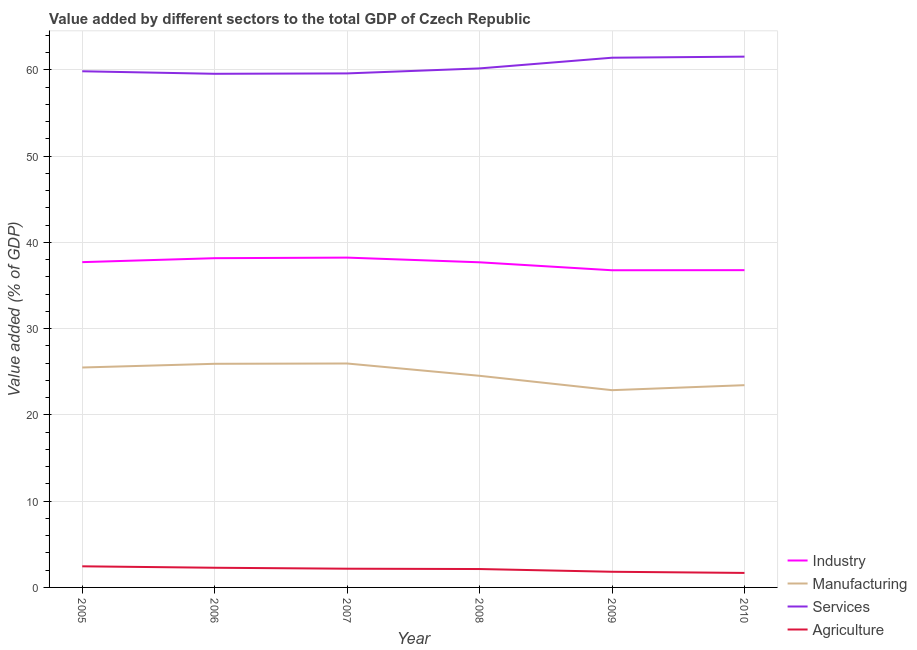How many different coloured lines are there?
Your answer should be very brief. 4. What is the value added by agricultural sector in 2010?
Offer a terse response. 1.68. Across all years, what is the maximum value added by industrial sector?
Your answer should be very brief. 38.24. Across all years, what is the minimum value added by industrial sector?
Your answer should be very brief. 36.77. What is the total value added by services sector in the graph?
Offer a terse response. 362.1. What is the difference between the value added by manufacturing sector in 2009 and that in 2010?
Provide a short and direct response. -0.58. What is the difference between the value added by industrial sector in 2009 and the value added by manufacturing sector in 2010?
Offer a very short reply. 13.32. What is the average value added by services sector per year?
Your answer should be compact. 60.35. In the year 2005, what is the difference between the value added by industrial sector and value added by services sector?
Keep it short and to the point. -22.13. In how many years, is the value added by manufacturing sector greater than 14 %?
Make the answer very short. 6. What is the ratio of the value added by services sector in 2007 to that in 2009?
Offer a terse response. 0.97. Is the value added by manufacturing sector in 2005 less than that in 2008?
Offer a terse response. No. What is the difference between the highest and the second highest value added by industrial sector?
Your answer should be compact. 0.07. What is the difference between the highest and the lowest value added by industrial sector?
Your answer should be very brief. 1.47. Is it the case that in every year, the sum of the value added by industrial sector and value added by manufacturing sector is greater than the value added by services sector?
Your answer should be very brief. No. Is the value added by industrial sector strictly greater than the value added by agricultural sector over the years?
Offer a very short reply. Yes. How many lines are there?
Keep it short and to the point. 4. Are the values on the major ticks of Y-axis written in scientific E-notation?
Keep it short and to the point. No. Does the graph contain any zero values?
Your answer should be compact. No. Where does the legend appear in the graph?
Your answer should be compact. Bottom right. How many legend labels are there?
Provide a succinct answer. 4. What is the title of the graph?
Give a very brief answer. Value added by different sectors to the total GDP of Czech Republic. Does "Payroll services" appear as one of the legend labels in the graph?
Provide a short and direct response. No. What is the label or title of the X-axis?
Give a very brief answer. Year. What is the label or title of the Y-axis?
Offer a very short reply. Value added (% of GDP). What is the Value added (% of GDP) in Industry in 2005?
Your answer should be very brief. 37.71. What is the Value added (% of GDP) of Manufacturing in 2005?
Ensure brevity in your answer.  25.5. What is the Value added (% of GDP) in Services in 2005?
Your answer should be very brief. 59.84. What is the Value added (% of GDP) of Agriculture in 2005?
Ensure brevity in your answer.  2.45. What is the Value added (% of GDP) of Industry in 2006?
Ensure brevity in your answer.  38.17. What is the Value added (% of GDP) in Manufacturing in 2006?
Provide a short and direct response. 25.93. What is the Value added (% of GDP) of Services in 2006?
Offer a terse response. 59.55. What is the Value added (% of GDP) of Agriculture in 2006?
Provide a succinct answer. 2.28. What is the Value added (% of GDP) of Industry in 2007?
Keep it short and to the point. 38.24. What is the Value added (% of GDP) of Manufacturing in 2007?
Ensure brevity in your answer.  25.96. What is the Value added (% of GDP) of Services in 2007?
Your answer should be very brief. 59.59. What is the Value added (% of GDP) in Agriculture in 2007?
Your answer should be very brief. 2.17. What is the Value added (% of GDP) in Industry in 2008?
Your answer should be very brief. 37.69. What is the Value added (% of GDP) of Manufacturing in 2008?
Ensure brevity in your answer.  24.53. What is the Value added (% of GDP) in Services in 2008?
Provide a succinct answer. 60.17. What is the Value added (% of GDP) in Agriculture in 2008?
Your answer should be compact. 2.13. What is the Value added (% of GDP) in Industry in 2009?
Offer a very short reply. 36.77. What is the Value added (% of GDP) in Manufacturing in 2009?
Your answer should be compact. 22.87. What is the Value added (% of GDP) of Services in 2009?
Provide a short and direct response. 61.41. What is the Value added (% of GDP) in Agriculture in 2009?
Offer a terse response. 1.82. What is the Value added (% of GDP) in Industry in 2010?
Ensure brevity in your answer.  36.78. What is the Value added (% of GDP) of Manufacturing in 2010?
Keep it short and to the point. 23.45. What is the Value added (% of GDP) of Services in 2010?
Provide a succinct answer. 61.54. What is the Value added (% of GDP) in Agriculture in 2010?
Your answer should be very brief. 1.68. Across all years, what is the maximum Value added (% of GDP) of Industry?
Provide a succinct answer. 38.24. Across all years, what is the maximum Value added (% of GDP) of Manufacturing?
Your answer should be very brief. 25.96. Across all years, what is the maximum Value added (% of GDP) of Services?
Your response must be concise. 61.54. Across all years, what is the maximum Value added (% of GDP) in Agriculture?
Provide a succinct answer. 2.45. Across all years, what is the minimum Value added (% of GDP) in Industry?
Offer a terse response. 36.77. Across all years, what is the minimum Value added (% of GDP) of Manufacturing?
Ensure brevity in your answer.  22.87. Across all years, what is the minimum Value added (% of GDP) of Services?
Your response must be concise. 59.55. Across all years, what is the minimum Value added (% of GDP) in Agriculture?
Give a very brief answer. 1.68. What is the total Value added (% of GDP) in Industry in the graph?
Provide a short and direct response. 225.37. What is the total Value added (% of GDP) of Manufacturing in the graph?
Ensure brevity in your answer.  148.24. What is the total Value added (% of GDP) in Services in the graph?
Your response must be concise. 362.1. What is the total Value added (% of GDP) of Agriculture in the graph?
Your response must be concise. 12.53. What is the difference between the Value added (% of GDP) of Industry in 2005 and that in 2006?
Provide a succinct answer. -0.46. What is the difference between the Value added (% of GDP) in Manufacturing in 2005 and that in 2006?
Offer a terse response. -0.43. What is the difference between the Value added (% of GDP) of Services in 2005 and that in 2006?
Provide a short and direct response. 0.29. What is the difference between the Value added (% of GDP) of Agriculture in 2005 and that in 2006?
Keep it short and to the point. 0.17. What is the difference between the Value added (% of GDP) of Industry in 2005 and that in 2007?
Give a very brief answer. -0.53. What is the difference between the Value added (% of GDP) of Manufacturing in 2005 and that in 2007?
Give a very brief answer. -0.46. What is the difference between the Value added (% of GDP) in Services in 2005 and that in 2007?
Your answer should be compact. 0.25. What is the difference between the Value added (% of GDP) in Agriculture in 2005 and that in 2007?
Give a very brief answer. 0.28. What is the difference between the Value added (% of GDP) in Industry in 2005 and that in 2008?
Keep it short and to the point. 0.02. What is the difference between the Value added (% of GDP) in Manufacturing in 2005 and that in 2008?
Offer a terse response. 0.96. What is the difference between the Value added (% of GDP) of Services in 2005 and that in 2008?
Your answer should be very brief. -0.33. What is the difference between the Value added (% of GDP) in Agriculture in 2005 and that in 2008?
Your answer should be compact. 0.31. What is the difference between the Value added (% of GDP) of Industry in 2005 and that in 2009?
Provide a succinct answer. 0.94. What is the difference between the Value added (% of GDP) of Manufacturing in 2005 and that in 2009?
Ensure brevity in your answer.  2.63. What is the difference between the Value added (% of GDP) of Services in 2005 and that in 2009?
Make the answer very short. -1.57. What is the difference between the Value added (% of GDP) of Agriculture in 2005 and that in 2009?
Offer a terse response. 0.63. What is the difference between the Value added (% of GDP) in Industry in 2005 and that in 2010?
Provide a succinct answer. 0.93. What is the difference between the Value added (% of GDP) of Manufacturing in 2005 and that in 2010?
Your response must be concise. 2.05. What is the difference between the Value added (% of GDP) in Services in 2005 and that in 2010?
Your answer should be very brief. -1.7. What is the difference between the Value added (% of GDP) in Agriculture in 2005 and that in 2010?
Provide a short and direct response. 0.77. What is the difference between the Value added (% of GDP) of Industry in 2006 and that in 2007?
Your answer should be very brief. -0.07. What is the difference between the Value added (% of GDP) of Manufacturing in 2006 and that in 2007?
Offer a terse response. -0.04. What is the difference between the Value added (% of GDP) in Services in 2006 and that in 2007?
Your answer should be very brief. -0.05. What is the difference between the Value added (% of GDP) in Agriculture in 2006 and that in 2007?
Provide a short and direct response. 0.11. What is the difference between the Value added (% of GDP) of Industry in 2006 and that in 2008?
Offer a very short reply. 0.48. What is the difference between the Value added (% of GDP) of Manufacturing in 2006 and that in 2008?
Ensure brevity in your answer.  1.39. What is the difference between the Value added (% of GDP) of Services in 2006 and that in 2008?
Your answer should be very brief. -0.63. What is the difference between the Value added (% of GDP) of Agriculture in 2006 and that in 2008?
Keep it short and to the point. 0.15. What is the difference between the Value added (% of GDP) in Industry in 2006 and that in 2009?
Your answer should be very brief. 1.4. What is the difference between the Value added (% of GDP) of Manufacturing in 2006 and that in 2009?
Offer a terse response. 3.06. What is the difference between the Value added (% of GDP) in Services in 2006 and that in 2009?
Your answer should be compact. -1.87. What is the difference between the Value added (% of GDP) of Agriculture in 2006 and that in 2009?
Your response must be concise. 0.47. What is the difference between the Value added (% of GDP) in Industry in 2006 and that in 2010?
Provide a short and direct response. 1.39. What is the difference between the Value added (% of GDP) of Manufacturing in 2006 and that in 2010?
Ensure brevity in your answer.  2.48. What is the difference between the Value added (% of GDP) of Services in 2006 and that in 2010?
Give a very brief answer. -1.99. What is the difference between the Value added (% of GDP) in Agriculture in 2006 and that in 2010?
Give a very brief answer. 0.6. What is the difference between the Value added (% of GDP) of Industry in 2007 and that in 2008?
Your answer should be compact. 0.54. What is the difference between the Value added (% of GDP) in Manufacturing in 2007 and that in 2008?
Your response must be concise. 1.43. What is the difference between the Value added (% of GDP) in Services in 2007 and that in 2008?
Give a very brief answer. -0.58. What is the difference between the Value added (% of GDP) in Agriculture in 2007 and that in 2008?
Keep it short and to the point. 0.04. What is the difference between the Value added (% of GDP) in Industry in 2007 and that in 2009?
Your response must be concise. 1.47. What is the difference between the Value added (% of GDP) in Manufacturing in 2007 and that in 2009?
Your response must be concise. 3.09. What is the difference between the Value added (% of GDP) in Services in 2007 and that in 2009?
Your answer should be compact. -1.82. What is the difference between the Value added (% of GDP) in Agriculture in 2007 and that in 2009?
Your answer should be compact. 0.35. What is the difference between the Value added (% of GDP) of Industry in 2007 and that in 2010?
Provide a short and direct response. 1.45. What is the difference between the Value added (% of GDP) of Manufacturing in 2007 and that in 2010?
Your answer should be compact. 2.51. What is the difference between the Value added (% of GDP) of Services in 2007 and that in 2010?
Your answer should be very brief. -1.94. What is the difference between the Value added (% of GDP) in Agriculture in 2007 and that in 2010?
Keep it short and to the point. 0.49. What is the difference between the Value added (% of GDP) of Industry in 2008 and that in 2009?
Your answer should be very brief. 0.92. What is the difference between the Value added (% of GDP) in Manufacturing in 2008 and that in 2009?
Make the answer very short. 1.67. What is the difference between the Value added (% of GDP) in Services in 2008 and that in 2009?
Offer a terse response. -1.24. What is the difference between the Value added (% of GDP) of Agriculture in 2008 and that in 2009?
Offer a very short reply. 0.32. What is the difference between the Value added (% of GDP) of Industry in 2008 and that in 2010?
Provide a short and direct response. 0.91. What is the difference between the Value added (% of GDP) in Manufacturing in 2008 and that in 2010?
Offer a terse response. 1.09. What is the difference between the Value added (% of GDP) in Services in 2008 and that in 2010?
Your answer should be very brief. -1.36. What is the difference between the Value added (% of GDP) of Agriculture in 2008 and that in 2010?
Your answer should be compact. 0.45. What is the difference between the Value added (% of GDP) in Industry in 2009 and that in 2010?
Your answer should be very brief. -0.01. What is the difference between the Value added (% of GDP) of Manufacturing in 2009 and that in 2010?
Ensure brevity in your answer.  -0.58. What is the difference between the Value added (% of GDP) in Services in 2009 and that in 2010?
Your answer should be compact. -0.12. What is the difference between the Value added (% of GDP) in Agriculture in 2009 and that in 2010?
Provide a succinct answer. 0.14. What is the difference between the Value added (% of GDP) of Industry in 2005 and the Value added (% of GDP) of Manufacturing in 2006?
Provide a short and direct response. 11.79. What is the difference between the Value added (% of GDP) in Industry in 2005 and the Value added (% of GDP) in Services in 2006?
Provide a succinct answer. -21.84. What is the difference between the Value added (% of GDP) in Industry in 2005 and the Value added (% of GDP) in Agriculture in 2006?
Your answer should be compact. 35.43. What is the difference between the Value added (% of GDP) in Manufacturing in 2005 and the Value added (% of GDP) in Services in 2006?
Provide a short and direct response. -34.05. What is the difference between the Value added (% of GDP) in Manufacturing in 2005 and the Value added (% of GDP) in Agriculture in 2006?
Keep it short and to the point. 23.21. What is the difference between the Value added (% of GDP) of Services in 2005 and the Value added (% of GDP) of Agriculture in 2006?
Provide a succinct answer. 57.56. What is the difference between the Value added (% of GDP) of Industry in 2005 and the Value added (% of GDP) of Manufacturing in 2007?
Provide a short and direct response. 11.75. What is the difference between the Value added (% of GDP) in Industry in 2005 and the Value added (% of GDP) in Services in 2007?
Your answer should be very brief. -21.88. What is the difference between the Value added (% of GDP) of Industry in 2005 and the Value added (% of GDP) of Agriculture in 2007?
Provide a succinct answer. 35.54. What is the difference between the Value added (% of GDP) of Manufacturing in 2005 and the Value added (% of GDP) of Services in 2007?
Ensure brevity in your answer.  -34.1. What is the difference between the Value added (% of GDP) in Manufacturing in 2005 and the Value added (% of GDP) in Agriculture in 2007?
Ensure brevity in your answer.  23.33. What is the difference between the Value added (% of GDP) of Services in 2005 and the Value added (% of GDP) of Agriculture in 2007?
Provide a succinct answer. 57.67. What is the difference between the Value added (% of GDP) in Industry in 2005 and the Value added (% of GDP) in Manufacturing in 2008?
Offer a terse response. 13.18. What is the difference between the Value added (% of GDP) of Industry in 2005 and the Value added (% of GDP) of Services in 2008?
Provide a succinct answer. -22.46. What is the difference between the Value added (% of GDP) in Industry in 2005 and the Value added (% of GDP) in Agriculture in 2008?
Your answer should be very brief. 35.58. What is the difference between the Value added (% of GDP) in Manufacturing in 2005 and the Value added (% of GDP) in Services in 2008?
Keep it short and to the point. -34.68. What is the difference between the Value added (% of GDP) in Manufacturing in 2005 and the Value added (% of GDP) in Agriculture in 2008?
Provide a succinct answer. 23.36. What is the difference between the Value added (% of GDP) of Services in 2005 and the Value added (% of GDP) of Agriculture in 2008?
Offer a terse response. 57.71. What is the difference between the Value added (% of GDP) in Industry in 2005 and the Value added (% of GDP) in Manufacturing in 2009?
Your answer should be compact. 14.84. What is the difference between the Value added (% of GDP) in Industry in 2005 and the Value added (% of GDP) in Services in 2009?
Ensure brevity in your answer.  -23.7. What is the difference between the Value added (% of GDP) in Industry in 2005 and the Value added (% of GDP) in Agriculture in 2009?
Your response must be concise. 35.9. What is the difference between the Value added (% of GDP) of Manufacturing in 2005 and the Value added (% of GDP) of Services in 2009?
Your response must be concise. -35.92. What is the difference between the Value added (% of GDP) in Manufacturing in 2005 and the Value added (% of GDP) in Agriculture in 2009?
Offer a very short reply. 23.68. What is the difference between the Value added (% of GDP) of Services in 2005 and the Value added (% of GDP) of Agriculture in 2009?
Make the answer very short. 58.03. What is the difference between the Value added (% of GDP) in Industry in 2005 and the Value added (% of GDP) in Manufacturing in 2010?
Offer a very short reply. 14.26. What is the difference between the Value added (% of GDP) in Industry in 2005 and the Value added (% of GDP) in Services in 2010?
Ensure brevity in your answer.  -23.83. What is the difference between the Value added (% of GDP) of Industry in 2005 and the Value added (% of GDP) of Agriculture in 2010?
Provide a short and direct response. 36.03. What is the difference between the Value added (% of GDP) of Manufacturing in 2005 and the Value added (% of GDP) of Services in 2010?
Make the answer very short. -36.04. What is the difference between the Value added (% of GDP) in Manufacturing in 2005 and the Value added (% of GDP) in Agriculture in 2010?
Your answer should be very brief. 23.82. What is the difference between the Value added (% of GDP) in Services in 2005 and the Value added (% of GDP) in Agriculture in 2010?
Make the answer very short. 58.16. What is the difference between the Value added (% of GDP) of Industry in 2006 and the Value added (% of GDP) of Manufacturing in 2007?
Your answer should be very brief. 12.21. What is the difference between the Value added (% of GDP) of Industry in 2006 and the Value added (% of GDP) of Services in 2007?
Provide a short and direct response. -21.42. What is the difference between the Value added (% of GDP) of Industry in 2006 and the Value added (% of GDP) of Agriculture in 2007?
Provide a short and direct response. 36. What is the difference between the Value added (% of GDP) in Manufacturing in 2006 and the Value added (% of GDP) in Services in 2007?
Keep it short and to the point. -33.67. What is the difference between the Value added (% of GDP) in Manufacturing in 2006 and the Value added (% of GDP) in Agriculture in 2007?
Make the answer very short. 23.76. What is the difference between the Value added (% of GDP) in Services in 2006 and the Value added (% of GDP) in Agriculture in 2007?
Your answer should be compact. 57.38. What is the difference between the Value added (% of GDP) of Industry in 2006 and the Value added (% of GDP) of Manufacturing in 2008?
Your response must be concise. 13.64. What is the difference between the Value added (% of GDP) of Industry in 2006 and the Value added (% of GDP) of Services in 2008?
Give a very brief answer. -22. What is the difference between the Value added (% of GDP) in Industry in 2006 and the Value added (% of GDP) in Agriculture in 2008?
Your answer should be compact. 36.04. What is the difference between the Value added (% of GDP) of Manufacturing in 2006 and the Value added (% of GDP) of Services in 2008?
Offer a terse response. -34.25. What is the difference between the Value added (% of GDP) of Manufacturing in 2006 and the Value added (% of GDP) of Agriculture in 2008?
Provide a short and direct response. 23.79. What is the difference between the Value added (% of GDP) in Services in 2006 and the Value added (% of GDP) in Agriculture in 2008?
Your answer should be very brief. 57.41. What is the difference between the Value added (% of GDP) of Industry in 2006 and the Value added (% of GDP) of Manufacturing in 2009?
Your response must be concise. 15.3. What is the difference between the Value added (% of GDP) of Industry in 2006 and the Value added (% of GDP) of Services in 2009?
Ensure brevity in your answer.  -23.24. What is the difference between the Value added (% of GDP) of Industry in 2006 and the Value added (% of GDP) of Agriculture in 2009?
Give a very brief answer. 36.36. What is the difference between the Value added (% of GDP) in Manufacturing in 2006 and the Value added (% of GDP) in Services in 2009?
Your response must be concise. -35.49. What is the difference between the Value added (% of GDP) of Manufacturing in 2006 and the Value added (% of GDP) of Agriculture in 2009?
Your answer should be compact. 24.11. What is the difference between the Value added (% of GDP) in Services in 2006 and the Value added (% of GDP) in Agriculture in 2009?
Your answer should be compact. 57.73. What is the difference between the Value added (% of GDP) of Industry in 2006 and the Value added (% of GDP) of Manufacturing in 2010?
Provide a succinct answer. 14.72. What is the difference between the Value added (% of GDP) of Industry in 2006 and the Value added (% of GDP) of Services in 2010?
Your response must be concise. -23.37. What is the difference between the Value added (% of GDP) of Industry in 2006 and the Value added (% of GDP) of Agriculture in 2010?
Offer a terse response. 36.49. What is the difference between the Value added (% of GDP) of Manufacturing in 2006 and the Value added (% of GDP) of Services in 2010?
Your answer should be very brief. -35.61. What is the difference between the Value added (% of GDP) of Manufacturing in 2006 and the Value added (% of GDP) of Agriculture in 2010?
Your answer should be very brief. 24.25. What is the difference between the Value added (% of GDP) of Services in 2006 and the Value added (% of GDP) of Agriculture in 2010?
Your answer should be very brief. 57.87. What is the difference between the Value added (% of GDP) in Industry in 2007 and the Value added (% of GDP) in Manufacturing in 2008?
Make the answer very short. 13.7. What is the difference between the Value added (% of GDP) in Industry in 2007 and the Value added (% of GDP) in Services in 2008?
Ensure brevity in your answer.  -21.94. What is the difference between the Value added (% of GDP) of Industry in 2007 and the Value added (% of GDP) of Agriculture in 2008?
Your answer should be compact. 36.1. What is the difference between the Value added (% of GDP) in Manufacturing in 2007 and the Value added (% of GDP) in Services in 2008?
Your answer should be very brief. -34.21. What is the difference between the Value added (% of GDP) in Manufacturing in 2007 and the Value added (% of GDP) in Agriculture in 2008?
Offer a very short reply. 23.83. What is the difference between the Value added (% of GDP) of Services in 2007 and the Value added (% of GDP) of Agriculture in 2008?
Keep it short and to the point. 57.46. What is the difference between the Value added (% of GDP) of Industry in 2007 and the Value added (% of GDP) of Manufacturing in 2009?
Your answer should be very brief. 15.37. What is the difference between the Value added (% of GDP) in Industry in 2007 and the Value added (% of GDP) in Services in 2009?
Give a very brief answer. -23.18. What is the difference between the Value added (% of GDP) of Industry in 2007 and the Value added (% of GDP) of Agriculture in 2009?
Offer a terse response. 36.42. What is the difference between the Value added (% of GDP) of Manufacturing in 2007 and the Value added (% of GDP) of Services in 2009?
Ensure brevity in your answer.  -35.45. What is the difference between the Value added (% of GDP) in Manufacturing in 2007 and the Value added (% of GDP) in Agriculture in 2009?
Offer a very short reply. 24.15. What is the difference between the Value added (% of GDP) in Services in 2007 and the Value added (% of GDP) in Agriculture in 2009?
Your answer should be very brief. 57.78. What is the difference between the Value added (% of GDP) of Industry in 2007 and the Value added (% of GDP) of Manufacturing in 2010?
Offer a very short reply. 14.79. What is the difference between the Value added (% of GDP) of Industry in 2007 and the Value added (% of GDP) of Services in 2010?
Provide a short and direct response. -23.3. What is the difference between the Value added (% of GDP) in Industry in 2007 and the Value added (% of GDP) in Agriculture in 2010?
Keep it short and to the point. 36.56. What is the difference between the Value added (% of GDP) of Manufacturing in 2007 and the Value added (% of GDP) of Services in 2010?
Your answer should be compact. -35.58. What is the difference between the Value added (% of GDP) of Manufacturing in 2007 and the Value added (% of GDP) of Agriculture in 2010?
Make the answer very short. 24.28. What is the difference between the Value added (% of GDP) in Services in 2007 and the Value added (% of GDP) in Agriculture in 2010?
Ensure brevity in your answer.  57.91. What is the difference between the Value added (% of GDP) of Industry in 2008 and the Value added (% of GDP) of Manufacturing in 2009?
Keep it short and to the point. 14.82. What is the difference between the Value added (% of GDP) of Industry in 2008 and the Value added (% of GDP) of Services in 2009?
Ensure brevity in your answer.  -23.72. What is the difference between the Value added (% of GDP) in Industry in 2008 and the Value added (% of GDP) in Agriculture in 2009?
Give a very brief answer. 35.88. What is the difference between the Value added (% of GDP) in Manufacturing in 2008 and the Value added (% of GDP) in Services in 2009?
Make the answer very short. -36.88. What is the difference between the Value added (% of GDP) of Manufacturing in 2008 and the Value added (% of GDP) of Agriculture in 2009?
Offer a very short reply. 22.72. What is the difference between the Value added (% of GDP) of Services in 2008 and the Value added (% of GDP) of Agriculture in 2009?
Provide a succinct answer. 58.36. What is the difference between the Value added (% of GDP) in Industry in 2008 and the Value added (% of GDP) in Manufacturing in 2010?
Offer a very short reply. 14.24. What is the difference between the Value added (% of GDP) of Industry in 2008 and the Value added (% of GDP) of Services in 2010?
Provide a succinct answer. -23.84. What is the difference between the Value added (% of GDP) of Industry in 2008 and the Value added (% of GDP) of Agriculture in 2010?
Keep it short and to the point. 36.01. What is the difference between the Value added (% of GDP) in Manufacturing in 2008 and the Value added (% of GDP) in Services in 2010?
Offer a very short reply. -37. What is the difference between the Value added (% of GDP) of Manufacturing in 2008 and the Value added (% of GDP) of Agriculture in 2010?
Your answer should be very brief. 22.85. What is the difference between the Value added (% of GDP) of Services in 2008 and the Value added (% of GDP) of Agriculture in 2010?
Keep it short and to the point. 58.49. What is the difference between the Value added (% of GDP) of Industry in 2009 and the Value added (% of GDP) of Manufacturing in 2010?
Your answer should be very brief. 13.32. What is the difference between the Value added (% of GDP) in Industry in 2009 and the Value added (% of GDP) in Services in 2010?
Ensure brevity in your answer.  -24.77. What is the difference between the Value added (% of GDP) in Industry in 2009 and the Value added (% of GDP) in Agriculture in 2010?
Provide a short and direct response. 35.09. What is the difference between the Value added (% of GDP) of Manufacturing in 2009 and the Value added (% of GDP) of Services in 2010?
Ensure brevity in your answer.  -38.67. What is the difference between the Value added (% of GDP) of Manufacturing in 2009 and the Value added (% of GDP) of Agriculture in 2010?
Your response must be concise. 21.19. What is the difference between the Value added (% of GDP) in Services in 2009 and the Value added (% of GDP) in Agriculture in 2010?
Your answer should be compact. 59.73. What is the average Value added (% of GDP) in Industry per year?
Your answer should be compact. 37.56. What is the average Value added (% of GDP) of Manufacturing per year?
Offer a terse response. 24.71. What is the average Value added (% of GDP) of Services per year?
Keep it short and to the point. 60.35. What is the average Value added (% of GDP) of Agriculture per year?
Give a very brief answer. 2.09. In the year 2005, what is the difference between the Value added (% of GDP) in Industry and Value added (% of GDP) in Manufacturing?
Your answer should be compact. 12.21. In the year 2005, what is the difference between the Value added (% of GDP) of Industry and Value added (% of GDP) of Services?
Give a very brief answer. -22.13. In the year 2005, what is the difference between the Value added (% of GDP) of Industry and Value added (% of GDP) of Agriculture?
Your answer should be compact. 35.26. In the year 2005, what is the difference between the Value added (% of GDP) in Manufacturing and Value added (% of GDP) in Services?
Your response must be concise. -34.34. In the year 2005, what is the difference between the Value added (% of GDP) of Manufacturing and Value added (% of GDP) of Agriculture?
Provide a succinct answer. 23.05. In the year 2005, what is the difference between the Value added (% of GDP) of Services and Value added (% of GDP) of Agriculture?
Make the answer very short. 57.39. In the year 2006, what is the difference between the Value added (% of GDP) in Industry and Value added (% of GDP) in Manufacturing?
Your answer should be very brief. 12.25. In the year 2006, what is the difference between the Value added (% of GDP) of Industry and Value added (% of GDP) of Services?
Offer a terse response. -21.38. In the year 2006, what is the difference between the Value added (% of GDP) in Industry and Value added (% of GDP) in Agriculture?
Ensure brevity in your answer.  35.89. In the year 2006, what is the difference between the Value added (% of GDP) in Manufacturing and Value added (% of GDP) in Services?
Provide a succinct answer. -33.62. In the year 2006, what is the difference between the Value added (% of GDP) of Manufacturing and Value added (% of GDP) of Agriculture?
Ensure brevity in your answer.  23.64. In the year 2006, what is the difference between the Value added (% of GDP) of Services and Value added (% of GDP) of Agriculture?
Your answer should be very brief. 57.27. In the year 2007, what is the difference between the Value added (% of GDP) in Industry and Value added (% of GDP) in Manufacturing?
Your response must be concise. 12.28. In the year 2007, what is the difference between the Value added (% of GDP) in Industry and Value added (% of GDP) in Services?
Provide a short and direct response. -21.36. In the year 2007, what is the difference between the Value added (% of GDP) of Industry and Value added (% of GDP) of Agriculture?
Offer a very short reply. 36.07. In the year 2007, what is the difference between the Value added (% of GDP) in Manufacturing and Value added (% of GDP) in Services?
Give a very brief answer. -33.63. In the year 2007, what is the difference between the Value added (% of GDP) of Manufacturing and Value added (% of GDP) of Agriculture?
Provide a short and direct response. 23.79. In the year 2007, what is the difference between the Value added (% of GDP) in Services and Value added (% of GDP) in Agriculture?
Ensure brevity in your answer.  57.42. In the year 2008, what is the difference between the Value added (% of GDP) in Industry and Value added (% of GDP) in Manufacturing?
Your answer should be compact. 13.16. In the year 2008, what is the difference between the Value added (% of GDP) in Industry and Value added (% of GDP) in Services?
Provide a succinct answer. -22.48. In the year 2008, what is the difference between the Value added (% of GDP) of Industry and Value added (% of GDP) of Agriculture?
Provide a short and direct response. 35.56. In the year 2008, what is the difference between the Value added (% of GDP) of Manufacturing and Value added (% of GDP) of Services?
Your response must be concise. -35.64. In the year 2008, what is the difference between the Value added (% of GDP) in Manufacturing and Value added (% of GDP) in Agriculture?
Offer a very short reply. 22.4. In the year 2008, what is the difference between the Value added (% of GDP) in Services and Value added (% of GDP) in Agriculture?
Provide a short and direct response. 58.04. In the year 2009, what is the difference between the Value added (% of GDP) in Industry and Value added (% of GDP) in Manufacturing?
Make the answer very short. 13.9. In the year 2009, what is the difference between the Value added (% of GDP) of Industry and Value added (% of GDP) of Services?
Ensure brevity in your answer.  -24.64. In the year 2009, what is the difference between the Value added (% of GDP) in Industry and Value added (% of GDP) in Agriculture?
Provide a succinct answer. 34.96. In the year 2009, what is the difference between the Value added (% of GDP) in Manufacturing and Value added (% of GDP) in Services?
Provide a succinct answer. -38.54. In the year 2009, what is the difference between the Value added (% of GDP) in Manufacturing and Value added (% of GDP) in Agriculture?
Provide a short and direct response. 21.05. In the year 2009, what is the difference between the Value added (% of GDP) of Services and Value added (% of GDP) of Agriculture?
Keep it short and to the point. 59.6. In the year 2010, what is the difference between the Value added (% of GDP) in Industry and Value added (% of GDP) in Manufacturing?
Your answer should be compact. 13.33. In the year 2010, what is the difference between the Value added (% of GDP) of Industry and Value added (% of GDP) of Services?
Make the answer very short. -24.75. In the year 2010, what is the difference between the Value added (% of GDP) of Industry and Value added (% of GDP) of Agriculture?
Provide a short and direct response. 35.1. In the year 2010, what is the difference between the Value added (% of GDP) in Manufacturing and Value added (% of GDP) in Services?
Your response must be concise. -38.09. In the year 2010, what is the difference between the Value added (% of GDP) of Manufacturing and Value added (% of GDP) of Agriculture?
Your response must be concise. 21.77. In the year 2010, what is the difference between the Value added (% of GDP) of Services and Value added (% of GDP) of Agriculture?
Provide a succinct answer. 59.86. What is the ratio of the Value added (% of GDP) in Industry in 2005 to that in 2006?
Offer a very short reply. 0.99. What is the ratio of the Value added (% of GDP) in Manufacturing in 2005 to that in 2006?
Offer a very short reply. 0.98. What is the ratio of the Value added (% of GDP) in Agriculture in 2005 to that in 2006?
Your response must be concise. 1.07. What is the ratio of the Value added (% of GDP) of Industry in 2005 to that in 2007?
Give a very brief answer. 0.99. What is the ratio of the Value added (% of GDP) in Manufacturing in 2005 to that in 2007?
Keep it short and to the point. 0.98. What is the ratio of the Value added (% of GDP) of Agriculture in 2005 to that in 2007?
Offer a very short reply. 1.13. What is the ratio of the Value added (% of GDP) of Industry in 2005 to that in 2008?
Your answer should be compact. 1. What is the ratio of the Value added (% of GDP) in Manufacturing in 2005 to that in 2008?
Give a very brief answer. 1.04. What is the ratio of the Value added (% of GDP) of Agriculture in 2005 to that in 2008?
Give a very brief answer. 1.15. What is the ratio of the Value added (% of GDP) in Industry in 2005 to that in 2009?
Keep it short and to the point. 1.03. What is the ratio of the Value added (% of GDP) in Manufacturing in 2005 to that in 2009?
Offer a terse response. 1.11. What is the ratio of the Value added (% of GDP) in Services in 2005 to that in 2009?
Offer a very short reply. 0.97. What is the ratio of the Value added (% of GDP) in Agriculture in 2005 to that in 2009?
Make the answer very short. 1.35. What is the ratio of the Value added (% of GDP) in Industry in 2005 to that in 2010?
Offer a terse response. 1.03. What is the ratio of the Value added (% of GDP) in Manufacturing in 2005 to that in 2010?
Offer a terse response. 1.09. What is the ratio of the Value added (% of GDP) of Services in 2005 to that in 2010?
Your response must be concise. 0.97. What is the ratio of the Value added (% of GDP) in Agriculture in 2005 to that in 2010?
Ensure brevity in your answer.  1.46. What is the ratio of the Value added (% of GDP) of Industry in 2006 to that in 2007?
Your answer should be very brief. 1. What is the ratio of the Value added (% of GDP) of Manufacturing in 2006 to that in 2007?
Ensure brevity in your answer.  1. What is the ratio of the Value added (% of GDP) of Services in 2006 to that in 2007?
Offer a terse response. 1. What is the ratio of the Value added (% of GDP) of Agriculture in 2006 to that in 2007?
Your answer should be very brief. 1.05. What is the ratio of the Value added (% of GDP) in Industry in 2006 to that in 2008?
Give a very brief answer. 1.01. What is the ratio of the Value added (% of GDP) in Manufacturing in 2006 to that in 2008?
Your answer should be compact. 1.06. What is the ratio of the Value added (% of GDP) of Services in 2006 to that in 2008?
Offer a very short reply. 0.99. What is the ratio of the Value added (% of GDP) of Agriculture in 2006 to that in 2008?
Your response must be concise. 1.07. What is the ratio of the Value added (% of GDP) in Industry in 2006 to that in 2009?
Provide a succinct answer. 1.04. What is the ratio of the Value added (% of GDP) in Manufacturing in 2006 to that in 2009?
Offer a terse response. 1.13. What is the ratio of the Value added (% of GDP) of Services in 2006 to that in 2009?
Your response must be concise. 0.97. What is the ratio of the Value added (% of GDP) in Agriculture in 2006 to that in 2009?
Offer a terse response. 1.26. What is the ratio of the Value added (% of GDP) in Industry in 2006 to that in 2010?
Your answer should be very brief. 1.04. What is the ratio of the Value added (% of GDP) in Manufacturing in 2006 to that in 2010?
Make the answer very short. 1.11. What is the ratio of the Value added (% of GDP) of Agriculture in 2006 to that in 2010?
Your answer should be very brief. 1.36. What is the ratio of the Value added (% of GDP) of Industry in 2007 to that in 2008?
Keep it short and to the point. 1.01. What is the ratio of the Value added (% of GDP) of Manufacturing in 2007 to that in 2008?
Your response must be concise. 1.06. What is the ratio of the Value added (% of GDP) in Agriculture in 2007 to that in 2008?
Ensure brevity in your answer.  1.02. What is the ratio of the Value added (% of GDP) in Industry in 2007 to that in 2009?
Provide a short and direct response. 1.04. What is the ratio of the Value added (% of GDP) of Manufacturing in 2007 to that in 2009?
Ensure brevity in your answer.  1.14. What is the ratio of the Value added (% of GDP) of Services in 2007 to that in 2009?
Offer a very short reply. 0.97. What is the ratio of the Value added (% of GDP) of Agriculture in 2007 to that in 2009?
Keep it short and to the point. 1.2. What is the ratio of the Value added (% of GDP) of Industry in 2007 to that in 2010?
Your answer should be very brief. 1.04. What is the ratio of the Value added (% of GDP) of Manufacturing in 2007 to that in 2010?
Offer a very short reply. 1.11. What is the ratio of the Value added (% of GDP) in Services in 2007 to that in 2010?
Your answer should be very brief. 0.97. What is the ratio of the Value added (% of GDP) of Agriculture in 2007 to that in 2010?
Your answer should be compact. 1.29. What is the ratio of the Value added (% of GDP) of Industry in 2008 to that in 2009?
Your answer should be very brief. 1.03. What is the ratio of the Value added (% of GDP) of Manufacturing in 2008 to that in 2009?
Offer a very short reply. 1.07. What is the ratio of the Value added (% of GDP) in Services in 2008 to that in 2009?
Keep it short and to the point. 0.98. What is the ratio of the Value added (% of GDP) in Agriculture in 2008 to that in 2009?
Your answer should be very brief. 1.17. What is the ratio of the Value added (% of GDP) in Industry in 2008 to that in 2010?
Keep it short and to the point. 1.02. What is the ratio of the Value added (% of GDP) in Manufacturing in 2008 to that in 2010?
Your response must be concise. 1.05. What is the ratio of the Value added (% of GDP) of Services in 2008 to that in 2010?
Make the answer very short. 0.98. What is the ratio of the Value added (% of GDP) of Agriculture in 2008 to that in 2010?
Offer a very short reply. 1.27. What is the ratio of the Value added (% of GDP) of Manufacturing in 2009 to that in 2010?
Make the answer very short. 0.98. What is the ratio of the Value added (% of GDP) in Services in 2009 to that in 2010?
Your answer should be compact. 1. What is the ratio of the Value added (% of GDP) in Agriculture in 2009 to that in 2010?
Offer a terse response. 1.08. What is the difference between the highest and the second highest Value added (% of GDP) in Industry?
Give a very brief answer. 0.07. What is the difference between the highest and the second highest Value added (% of GDP) in Manufacturing?
Provide a succinct answer. 0.04. What is the difference between the highest and the second highest Value added (% of GDP) of Services?
Make the answer very short. 0.12. What is the difference between the highest and the second highest Value added (% of GDP) of Agriculture?
Your response must be concise. 0.17. What is the difference between the highest and the lowest Value added (% of GDP) of Industry?
Make the answer very short. 1.47. What is the difference between the highest and the lowest Value added (% of GDP) of Manufacturing?
Keep it short and to the point. 3.09. What is the difference between the highest and the lowest Value added (% of GDP) in Services?
Provide a short and direct response. 1.99. What is the difference between the highest and the lowest Value added (% of GDP) of Agriculture?
Provide a succinct answer. 0.77. 